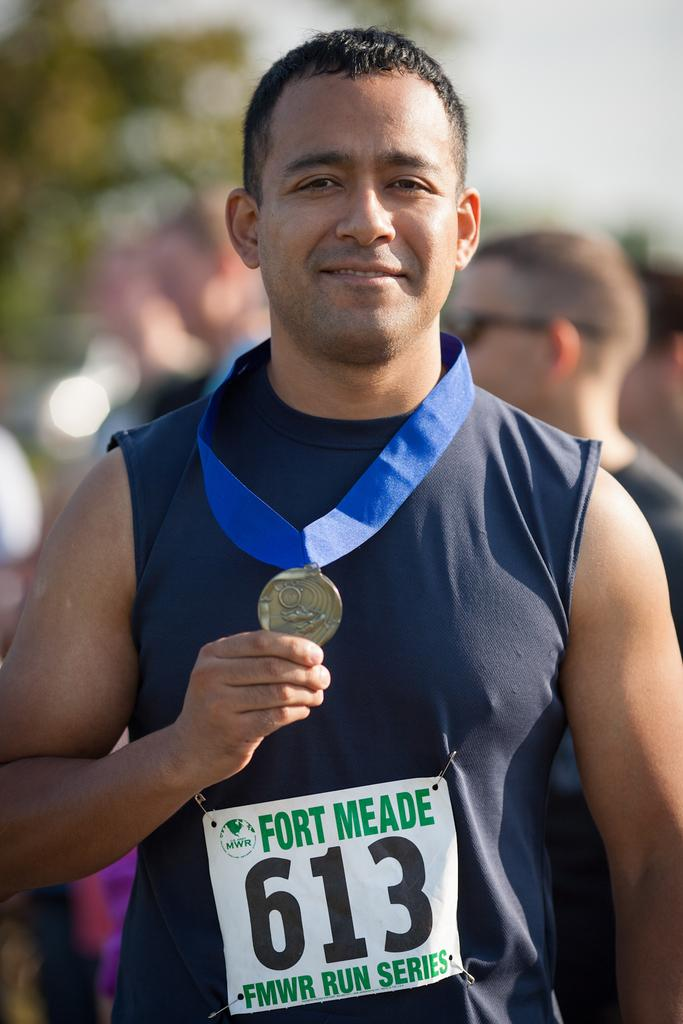<image>
Summarize the visual content of the image. Man wearing a medal and a sign which has the number 613. 